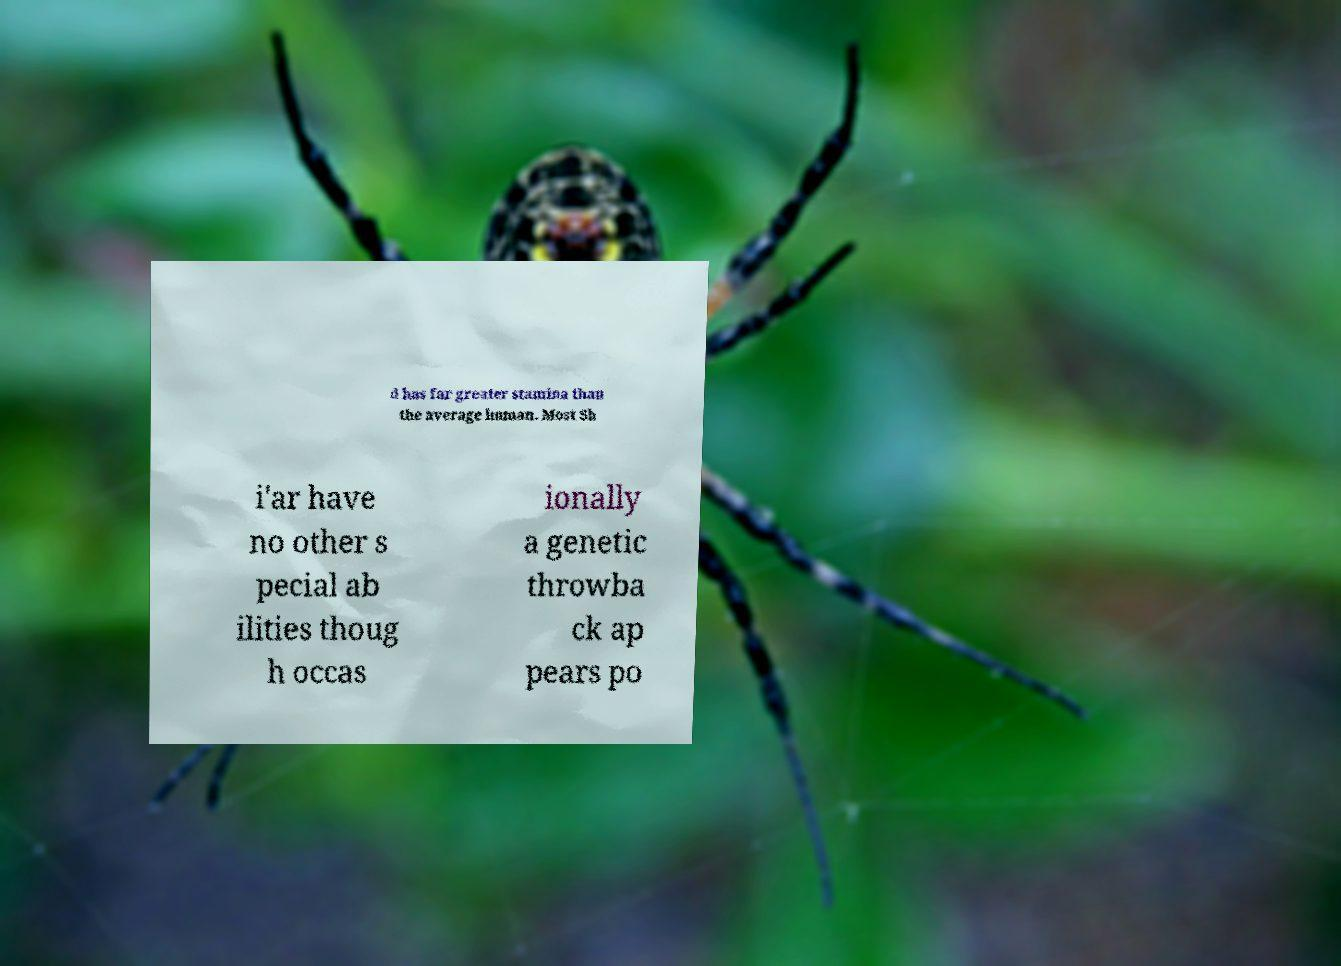Could you assist in decoding the text presented in this image and type it out clearly? d has far greater stamina than the average human. Most Sh i'ar have no other s pecial ab ilities thoug h occas ionally a genetic throwba ck ap pears po 